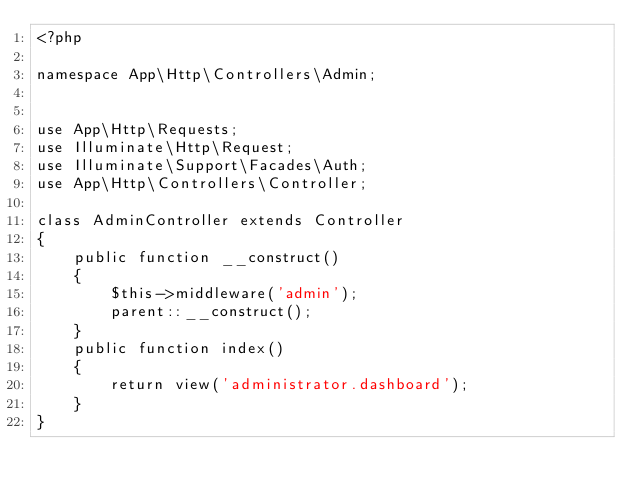<code> <loc_0><loc_0><loc_500><loc_500><_PHP_><?php

namespace App\Http\Controllers\Admin;


use App\Http\Requests;
use Illuminate\Http\Request;
use Illuminate\Support\Facades\Auth;
use App\Http\Controllers\Controller;

class AdminController extends Controller
{
    public function __construct()
    {
		$this->middleware('admin');
		parent::__construct();
	}
	public function index()
	{
		return view('administrator.dashboard');
	}
}</code> 